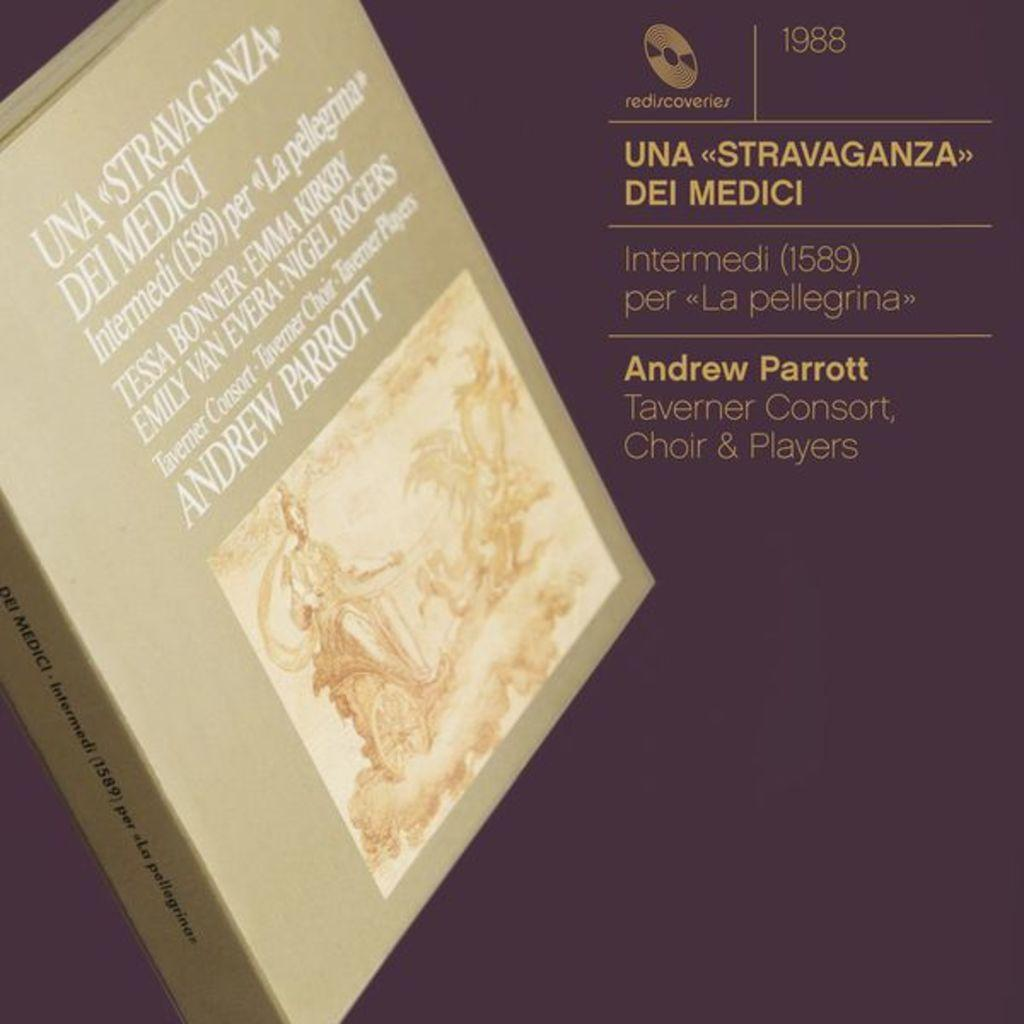<image>
Write a terse but informative summary of the picture. A music collection released in 1988 is performed by Andrew Parrott. 